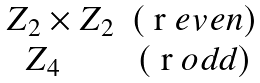Convert formula to latex. <formula><loc_0><loc_0><loc_500><loc_500>\begin{matrix} Z _ { 2 } \times Z _ { 2 } & ( $ r $ e v e n ) \\ Z _ { 4 } \quad & ( $ r $ o d d ) \\ \end{matrix}</formula> 